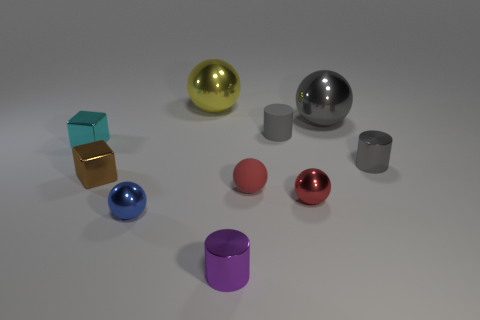How many small metal cylinders are there?
Make the answer very short. 2. There is a sphere that is behind the blue ball and to the left of the small purple thing; what color is it?
Make the answer very short. Yellow. What size is the yellow shiny object that is the same shape as the red shiny object?
Offer a terse response. Large. How many gray shiny cylinders are the same size as the blue metallic object?
Provide a succinct answer. 1. Are there any tiny blue metal things on the left side of the tiny gray rubber object?
Your response must be concise. Yes. What size is the red ball that is made of the same material as the big yellow object?
Ensure brevity in your answer.  Small. How many other matte balls are the same color as the matte ball?
Your answer should be very brief. 0. Is the number of tiny metal things behind the small red shiny object less than the number of balls on the right side of the blue metal ball?
Give a very brief answer. Yes. There is a shiny sphere behind the gray ball; what size is it?
Your answer should be compact. Large. There is a shiny sphere that is the same color as the matte cylinder; what size is it?
Provide a short and direct response. Large. 